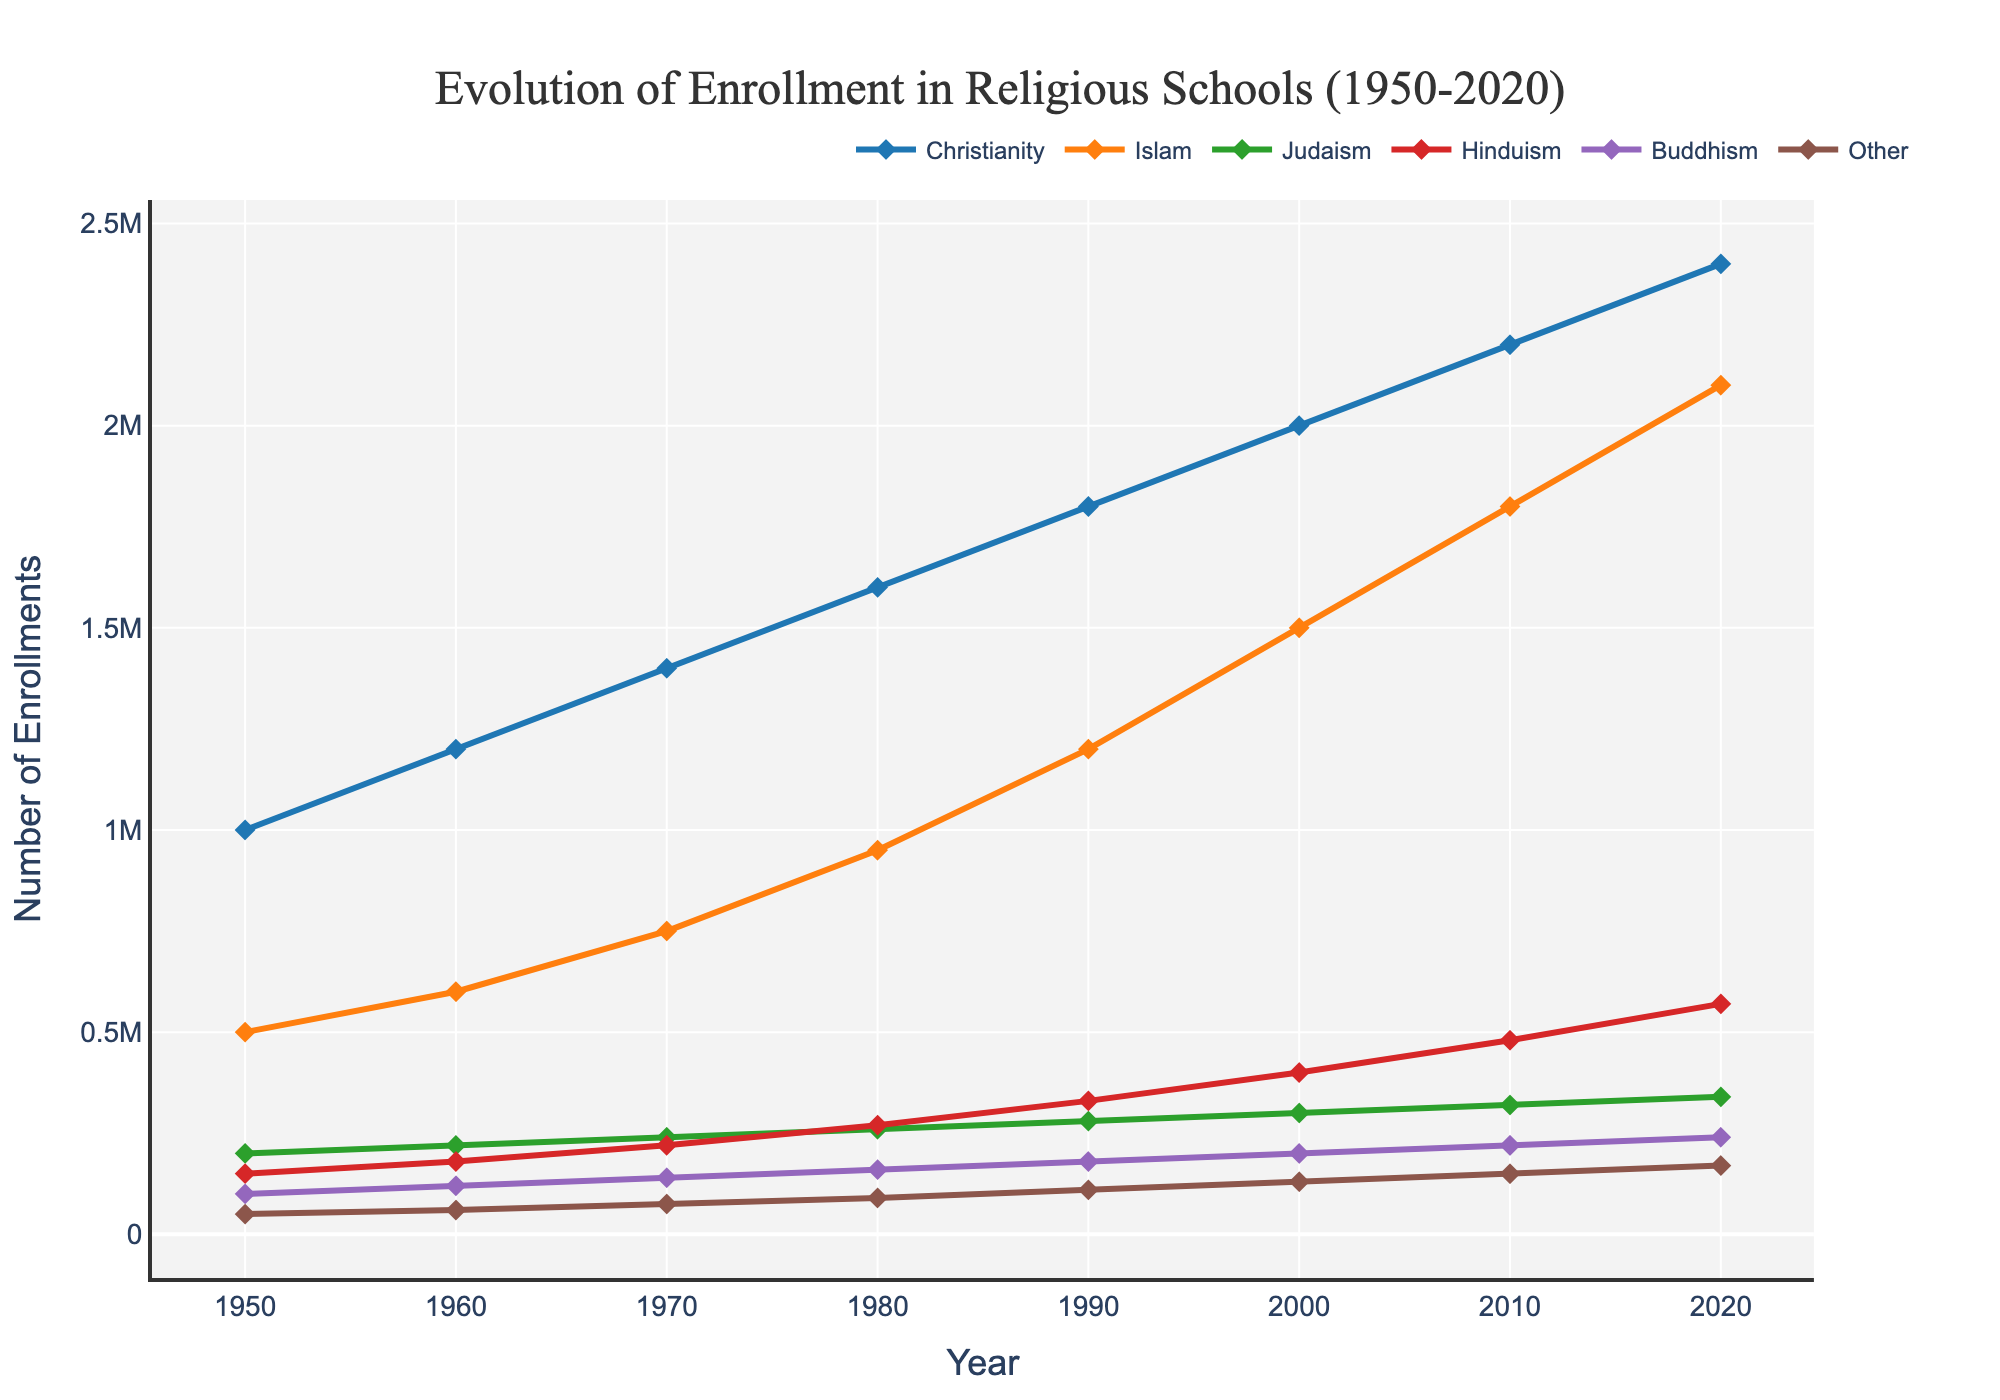How has the enrollment trend for Christianity and Islam been different from 1950 to 2020? To answer this, you compare the lines for Christianity and Islam. Both show an upward trend but Christianity's increases more steadily whereas Islam's increases more sharply starting around 1980.
Answer: Islam's trend increased more sharply When did Hinduism enrollment numbers surpass those of Judaism? Look at the intersections of the lines representing Hinduism and Judaism. They intersect between 1970 and 1980.
Answer: Between 1970 and 1980 What is the total enrollment for Christianity and Islam in the year 2000? Add the enrollment numbers for Christianity (2,000,000) and Islam (1,500,000) as shown for the year 2000.
Answer: 3,500,000 Compare the enrollment trend for Buddhism and Other faiths. What's the key difference? Observe the lines for Buddhism and Other faiths. Buddhism shows a steady increase while Other faiths also increase but at a slower rate.
Answer: Buddhism increased more steadily In which years did the enrollment in Judaism remain constant? Look at the line for Judaism and note the years where the line shows no change. Enrollment stayed relatively constant between 1950 and 1960, and 1960 and 1970.
Answer: 1950-1960 and 1960-1970 What is the percentage increase in enrollments for Hinduism from 1950 to 2020? First, find the enrollments for Hinduism in 1950 (150,000) and in 2020 (570,000). The percentage increase formula is ((New Value - Old Value) / Old Value) * 100.
Answer: 280% Which faith has shown the fastest growth rate overall? Identify which line on the chart has the steepest slope. Islam shows the fastest growth overall.
Answer: Islam What are the enrollment numbers for Buddhism in 1980 and 2020? What is the numerical increase? Check the enrollment values for Buddhism in 1980 (160,000) and 2020 (240,000) then subtract the 1980 value from the 2020 value.
Answer: 80,000 increase Which faiths show a linear growth pattern in enrollments? Look for lines that increase at a consistent rate throughout the chart. Christianity and Buddhism appear to exhibit a linear growth pattern.
Answer: Christianity and Buddhism 